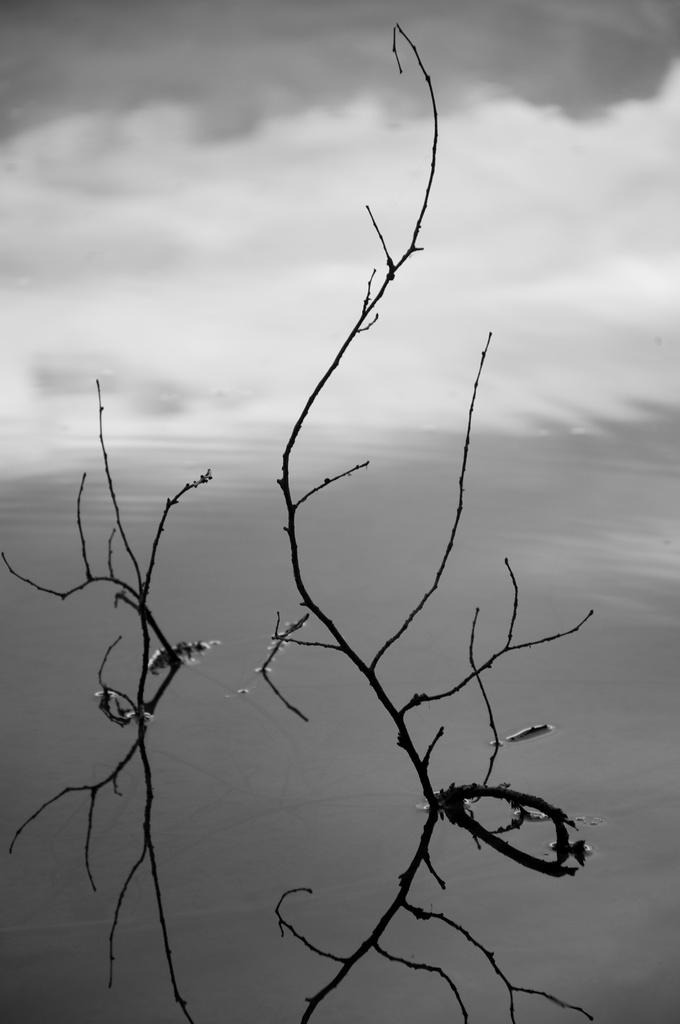What is the main feature in the foreground of the image? There is a water body in the foreground of the image. What can be seen within the water body? There are stems in the water. What is visible in the background of the image? The sky is visible in the image. What is the condition of the sky in the image? There are clouds in the sky. What is the average income of the people living near the water body in the image? There is no information about the income of people living near the water body in the image, as the focus is on the water body and its contents. 